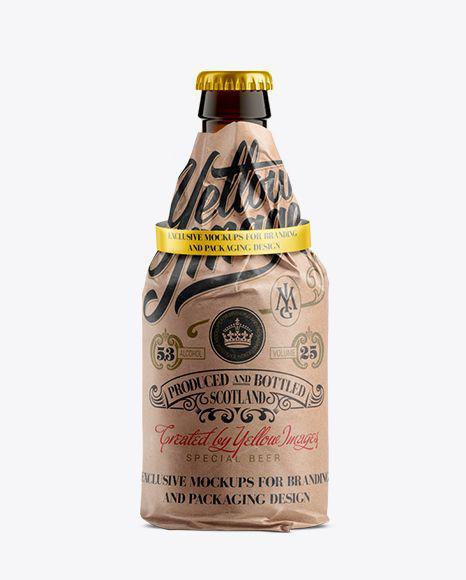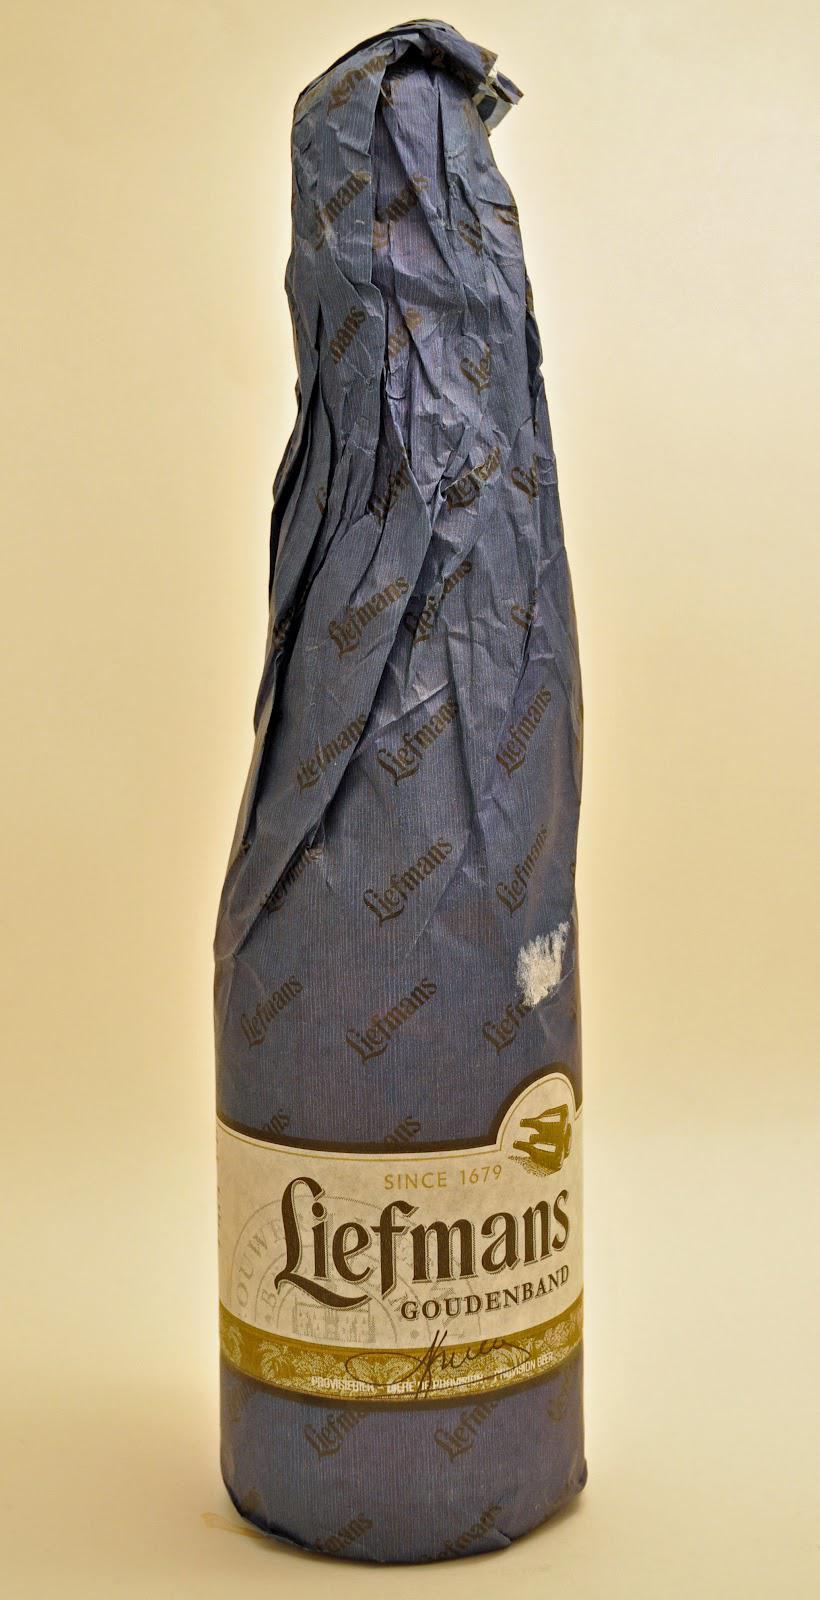The first image is the image on the left, the second image is the image on the right. Assess this claim about the two images: "Each image contains only paper-wrapped bottles, and the left image features one wide-bottomed bottled with a ring shape around the neck and its cap exposed.". Correct or not? Answer yes or no. Yes. The first image is the image on the left, the second image is the image on the right. Analyze the images presented: Is the assertion "There are exactly two bottles wrapped in paper." valid? Answer yes or no. Yes. 